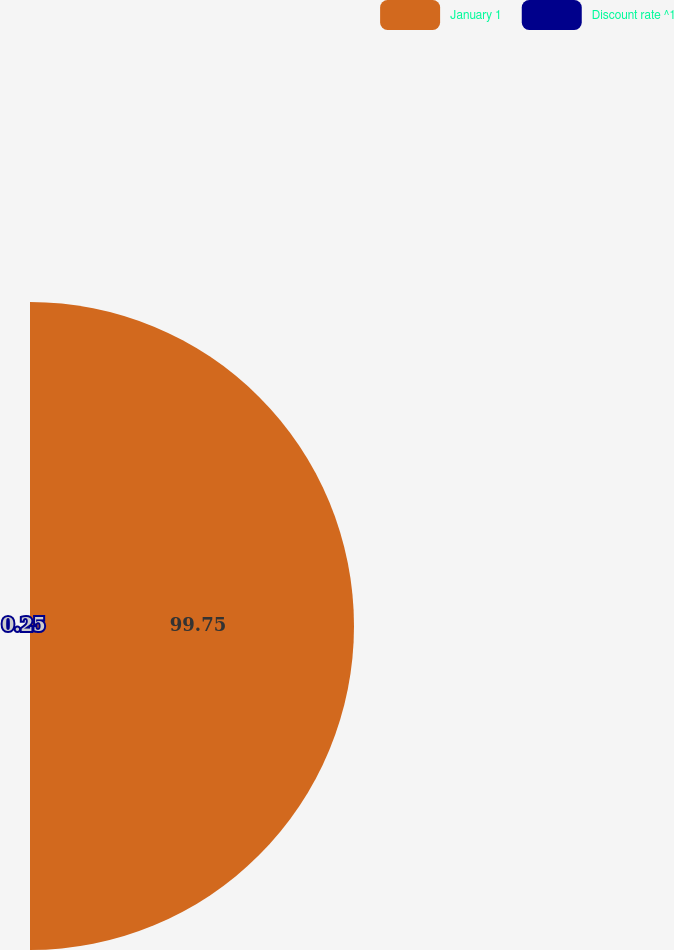Convert chart to OTSL. <chart><loc_0><loc_0><loc_500><loc_500><pie_chart><fcel>January 1<fcel>Discount rate ^1<nl><fcel>99.75%<fcel>0.25%<nl></chart> 